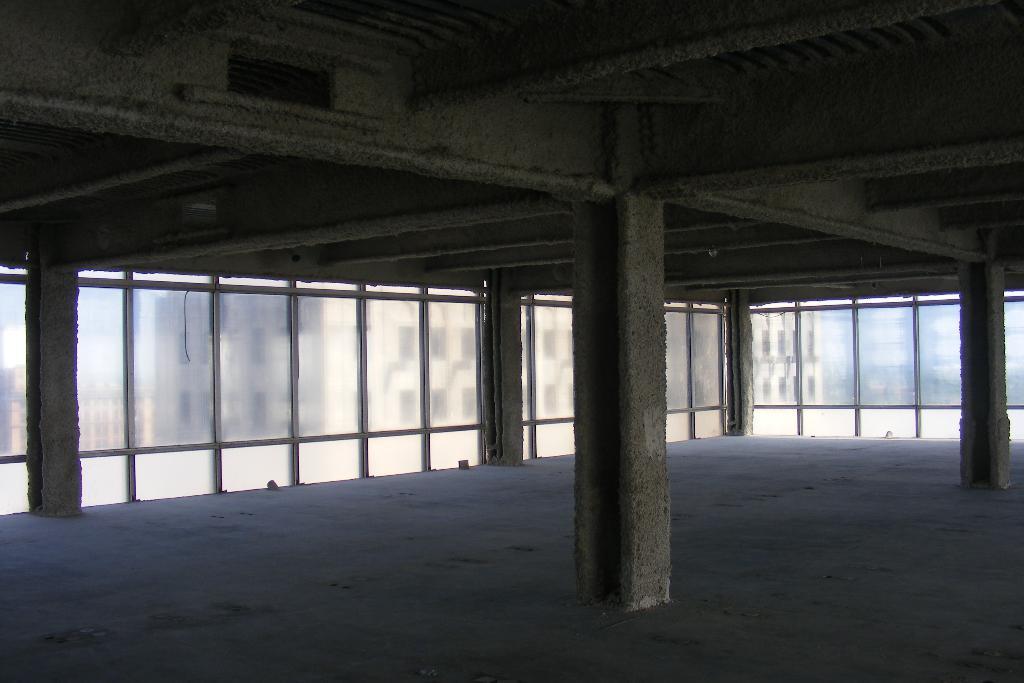Can you describe this image briefly? This image is taken from inside the building, In this image there are pillars, in the background there is a glass wall. At the top of the image there is a ceiling. 